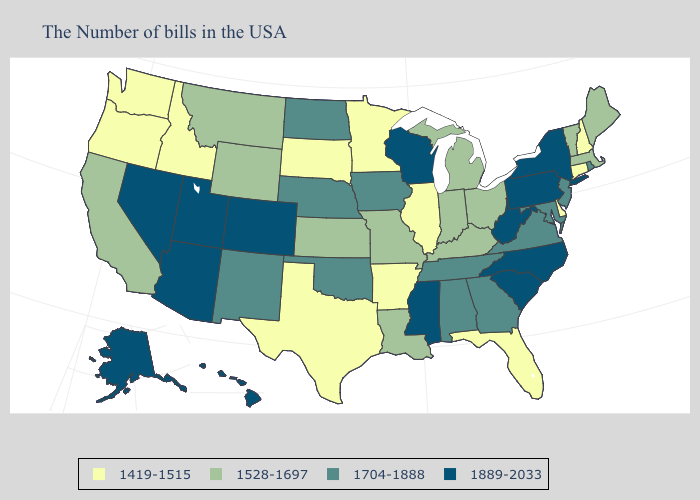What is the value of Nebraska?
Answer briefly. 1704-1888. What is the value of Indiana?
Give a very brief answer. 1528-1697. Name the states that have a value in the range 1704-1888?
Give a very brief answer. Rhode Island, New Jersey, Maryland, Virginia, Georgia, Alabama, Tennessee, Iowa, Nebraska, Oklahoma, North Dakota, New Mexico. What is the value of Wisconsin?
Write a very short answer. 1889-2033. What is the highest value in the South ?
Be succinct. 1889-2033. Does South Carolina have the lowest value in the South?
Concise answer only. No. What is the value of Texas?
Keep it brief. 1419-1515. What is the value of Connecticut?
Concise answer only. 1419-1515. What is the lowest value in the USA?
Quick response, please. 1419-1515. Which states have the lowest value in the MidWest?
Quick response, please. Illinois, Minnesota, South Dakota. Name the states that have a value in the range 1704-1888?
Keep it brief. Rhode Island, New Jersey, Maryland, Virginia, Georgia, Alabama, Tennessee, Iowa, Nebraska, Oklahoma, North Dakota, New Mexico. Among the states that border South Dakota , does Wyoming have the lowest value?
Answer briefly. No. What is the lowest value in the USA?
Keep it brief. 1419-1515. Which states have the highest value in the USA?
Keep it brief. New York, Pennsylvania, North Carolina, South Carolina, West Virginia, Wisconsin, Mississippi, Colorado, Utah, Arizona, Nevada, Alaska, Hawaii. Does New Jersey have the lowest value in the Northeast?
Be succinct. No. 